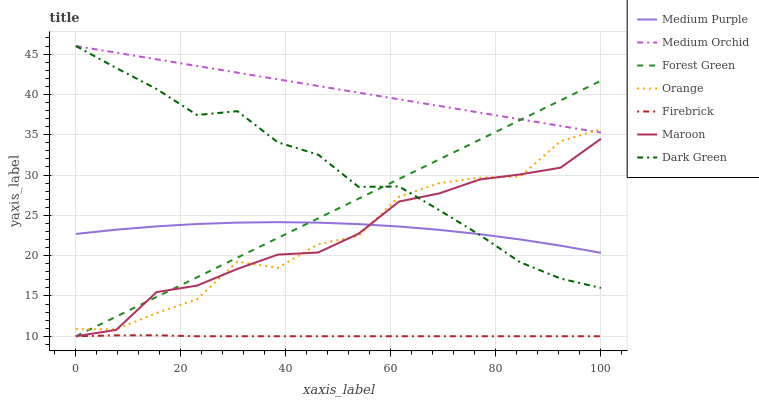Does Firebrick have the minimum area under the curve?
Answer yes or no. Yes. Does Medium Orchid have the maximum area under the curve?
Answer yes or no. Yes. Does Maroon have the minimum area under the curve?
Answer yes or no. No. Does Maroon have the maximum area under the curve?
Answer yes or no. No. Is Forest Green the smoothest?
Answer yes or no. Yes. Is Orange the roughest?
Answer yes or no. Yes. Is Medium Orchid the smoothest?
Answer yes or no. No. Is Medium Orchid the roughest?
Answer yes or no. No. Does Medium Orchid have the lowest value?
Answer yes or no. No. Does Maroon have the highest value?
Answer yes or no. No. Is Maroon less than Medium Orchid?
Answer yes or no. Yes. Is Medium Orchid greater than Medium Purple?
Answer yes or no. Yes. Does Maroon intersect Medium Orchid?
Answer yes or no. No. 